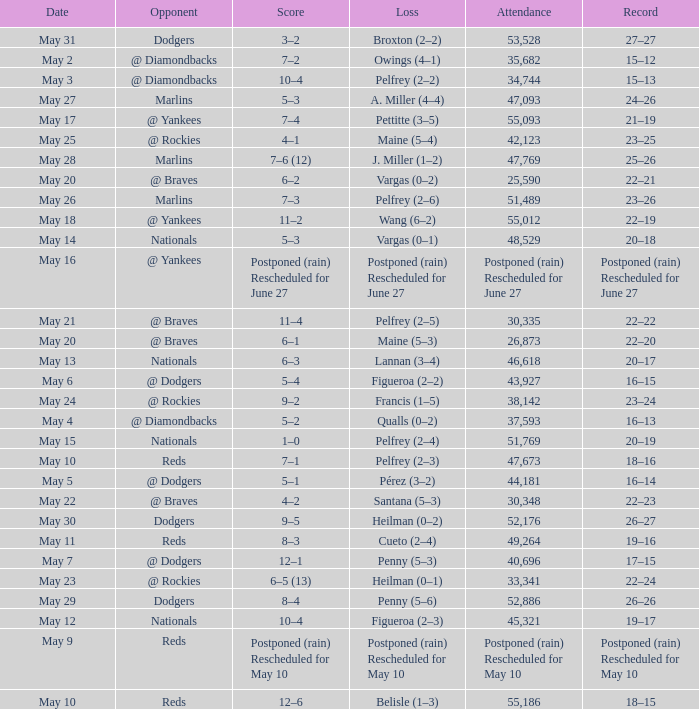Score of postponed (rain) rescheduled for June 27 had what loss? Postponed (rain) Rescheduled for June 27. 